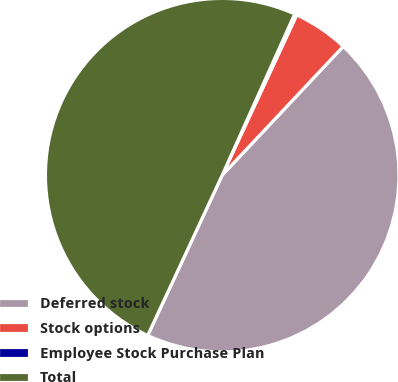Convert chart. <chart><loc_0><loc_0><loc_500><loc_500><pie_chart><fcel>Deferred stock<fcel>Stock options<fcel>Employee Stock Purchase Plan<fcel>Total<nl><fcel>44.92%<fcel>5.08%<fcel>0.2%<fcel>49.8%<nl></chart> 